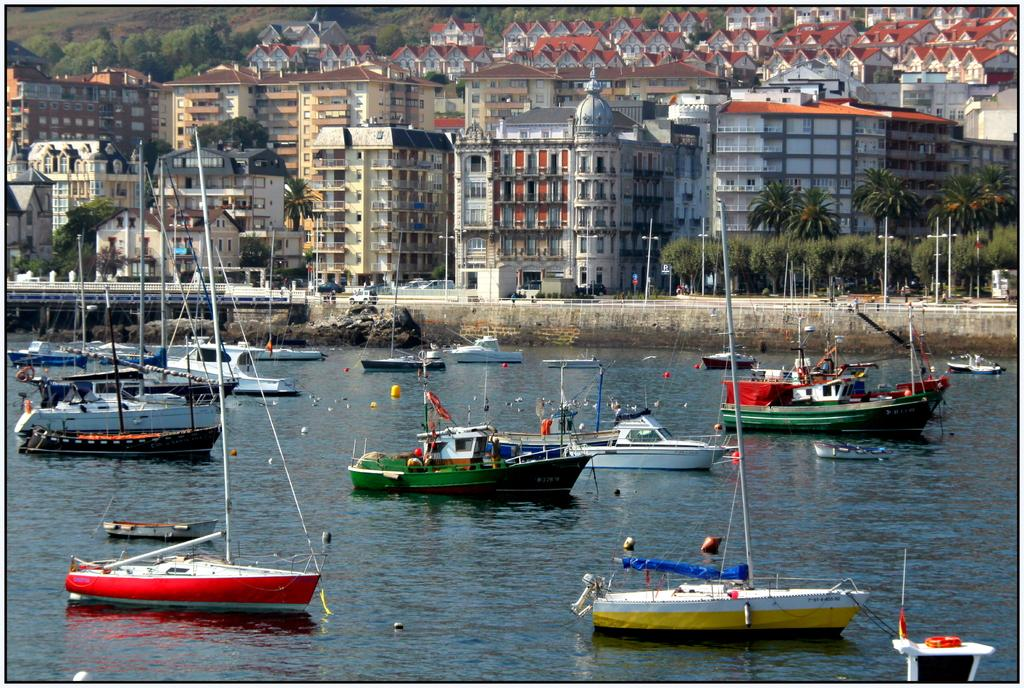What can be seen in the image that travels on water? There are ships in the image that travel on water. What objects are visible above the water in the image? There are poles with strings in the image that are visible above the water. What structures can be seen in the background of the image? There are buildings, trees, vehicles, a fence, and poles in the background of the image. What type of behavior can be observed in the income of the people in the image? There is no information about the income of people in the image, so it cannot be determined. Can you tell me how many mittens are present in the image? There are no mittens present in the image. 